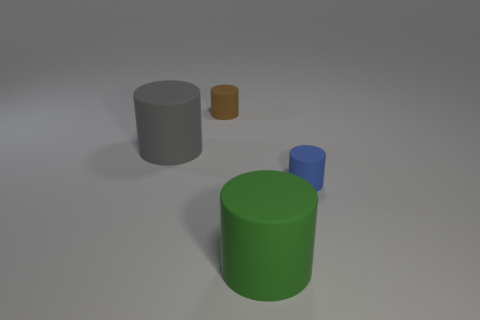Subtract all tiny brown cylinders. How many cylinders are left? 3 Add 2 large metallic things. How many objects exist? 6 Subtract all brown cylinders. How many cylinders are left? 3 Add 1 gray balls. How many gray balls exist? 1 Subtract 0 purple cylinders. How many objects are left? 4 Subtract all brown cylinders. Subtract all cyan blocks. How many cylinders are left? 3 Subtract all purple blocks. How many blue cylinders are left? 1 Subtract all large brown metal cylinders. Subtract all green rubber cylinders. How many objects are left? 3 Add 3 green objects. How many green objects are left? 4 